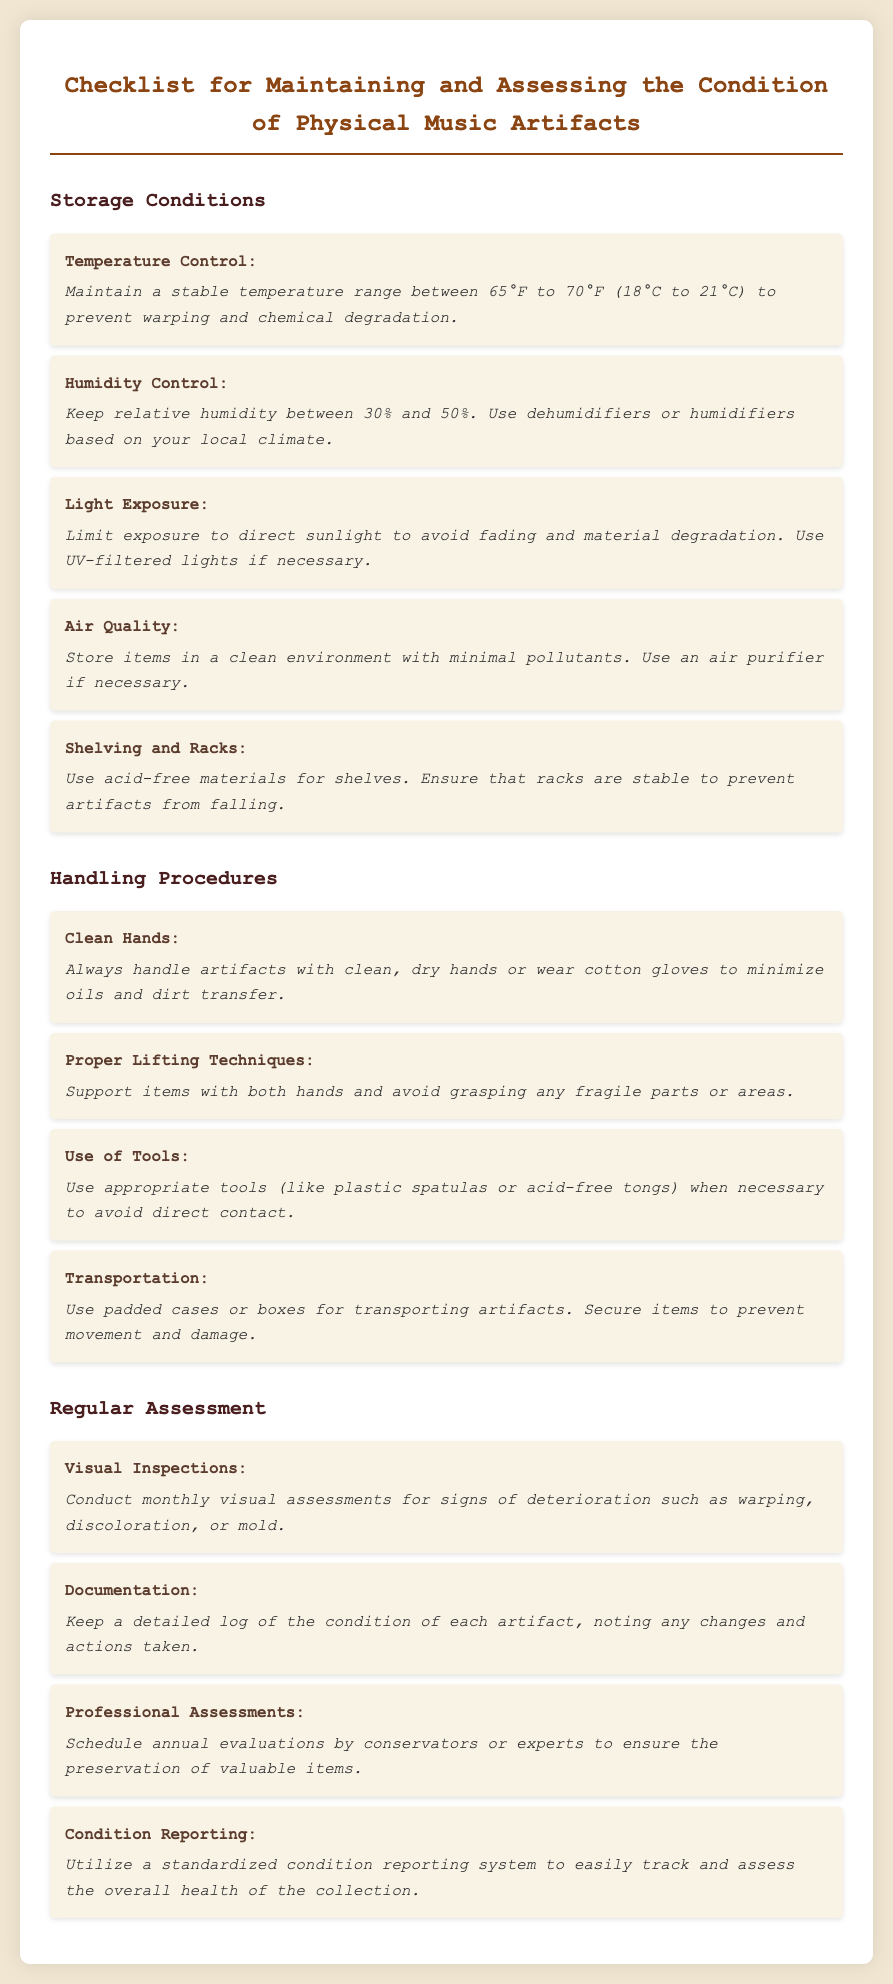What is the recommended temperature range for storage? The document states that the stable temperature range should be between 65°F to 70°F (18°C to 21°C) to prevent warping and chemical degradation.
Answer: 65°F to 70°F (18°C to 21°C) What is the ideal relative humidity for preserving music artifacts? It is mentioned in the document that relative humidity should be kept between 30% and 50%.
Answer: 30% and 50% What should be used to limit light exposure? The checklist advises using UV-filtered lights if necessary to avoid fading and material degradation from direct sunlight.
Answer: UV-filtered lights How often should visual inspections be conducted? According to the document, monthly visual assessments are to be conducted for signs of deterioration.
Answer: Monthly What types of gloves are recommended when handling artifacts? The document recommends wearing cotton gloves to minimize oils and dirt transfer during handling.
Answer: Cotton gloves What can be used to transport artifacts safely? The checklist states that padded cases or boxes should be used for transporting artifacts.
Answer: Padded cases or boxes Who should conduct annual evaluations of the artifacts? The document recommends scheduling evaluations by conservators or experts for preservation.
Answer: Conservators or experts What material should shelves be made of? It is advised in the document that shelves should be made of acid-free materials.
Answer: Acid-free materials What is the first step in the handling procedures? The document emphasizes that handling artifacts should begin with clean, dry hands or wearing gloves.
Answer: Clean hands 